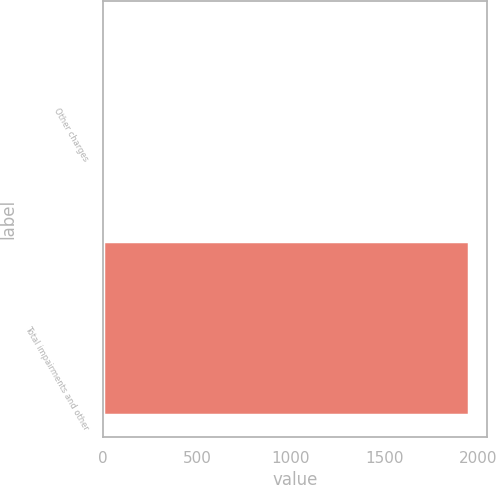Convert chart. <chart><loc_0><loc_0><loc_500><loc_500><bar_chart><fcel>Other charges<fcel>Total impairments and other<nl><fcel>1<fcel>1949<nl></chart> 